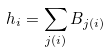Convert formula to latex. <formula><loc_0><loc_0><loc_500><loc_500>h _ { i } = \sum _ { j ( i ) } B _ { j ( i ) }</formula> 